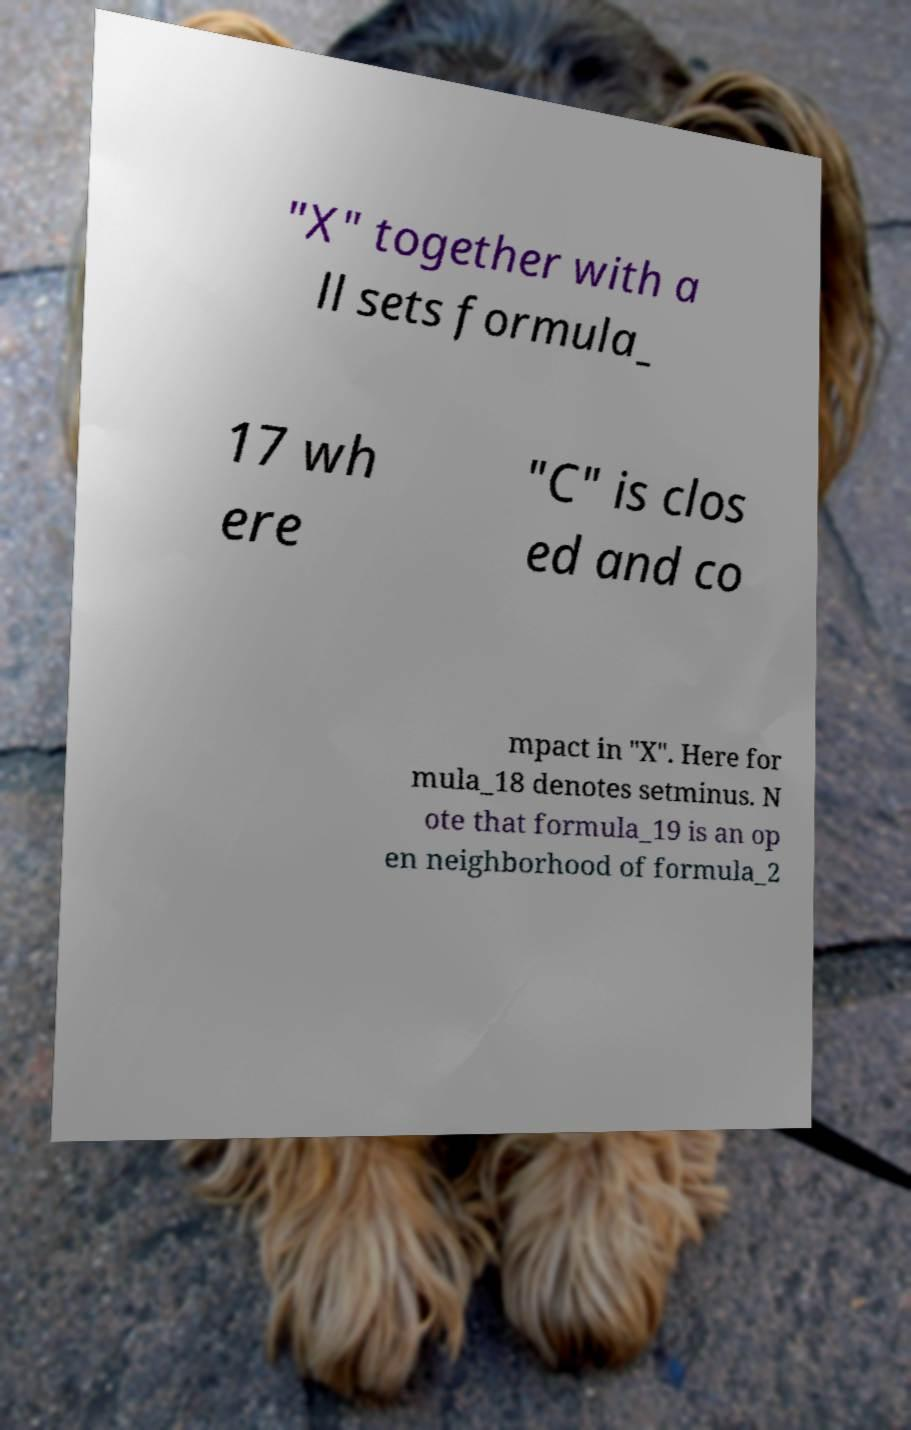Could you assist in decoding the text presented in this image and type it out clearly? "X" together with a ll sets formula_ 17 wh ere "C" is clos ed and co mpact in "X". Here for mula_18 denotes setminus. N ote that formula_19 is an op en neighborhood of formula_2 